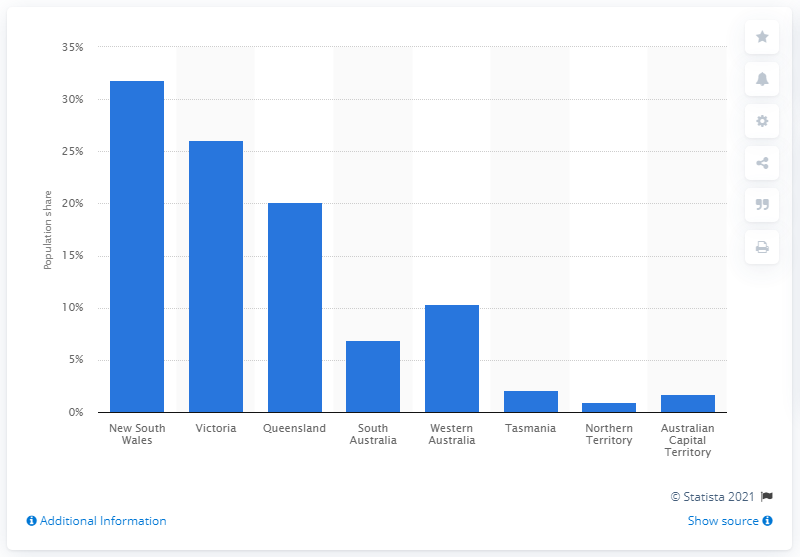Identify some key points in this picture. According to the data, 31.8% of the Australian population resided in the state of New South Wales. In March 2020, approximately 31.8% of the Australian population resided in the state of New South Wales. 